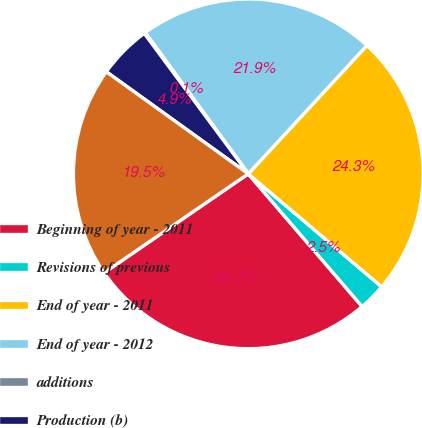<chart> <loc_0><loc_0><loc_500><loc_500><pie_chart><fcel>Beginning of year - 2011<fcel>Revisions of previous<fcel>End of year - 2011<fcel>End of year - 2012<fcel>additions<fcel>Production (b)<fcel>End of year - 2013<nl><fcel>26.71%<fcel>2.53%<fcel>24.31%<fcel>21.9%<fcel>0.12%<fcel>4.93%<fcel>19.5%<nl></chart> 